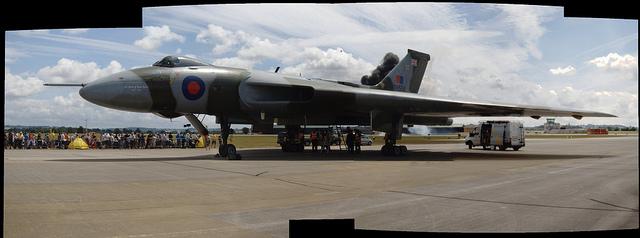What kind of aircraft is this?
Concise answer only. Jet. What is the color of the plane?
Give a very brief answer. Gray. What color is this plane?
Answer briefly. Gray. What kind of plane is this?
Quick response, please. Military. Is the plane in a hangar?
Be succinct. No. What color is the spot on the plane?
Quick response, please. Red. Could this be a pachyderm?
Be succinct. No. What does the word on the plane say?
Write a very short answer. Air force. How many wheels are on the plane?
Write a very short answer. 6. 